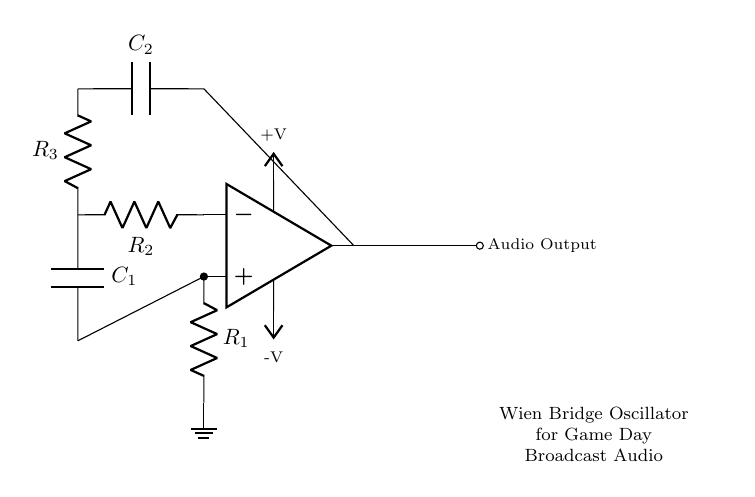What is the main function of the Wien bridge oscillator? The main function of the Wien bridge oscillator is to generate audio frequencies, which can be used for game day broadcast audio.
Answer: Generate audio frequencies Which component in the circuit acts as the amplifier? The component that acts as the amplifier in the circuit is the operational amplifier. It is located at the center of the diagram.
Answer: Operational amplifier How many resistors are in the circuit? There are three resistors in the circuit, labeled R1, R2, and R3.
Answer: Three What is the role of capacitors in this oscillator circuit? The capacitors, labeled C1 and C2, are used to set the frequency of oscillation based on their values in conjunction with the resistors.
Answer: Set the frequency What is the purpose of the ground connection in the circuit? The ground connection serves as a reference point for the voltages in the circuit, ensuring stability and proper functioning of the circuit components, particularly the op amp.
Answer: Reference point for voltages What does the output node indicate in the circuit? The output node indicates where the audio signal is taken from the oscillator for broadcasting on game day.
Answer: Audio output How are the resistors and capacitors connected in the circuit? The resistors and capacitors are connected in a specific way to form a feedback loop that determines the oscillation frequency; R2 and C1 create a part of this loop.
Answer: Form feedback loop 